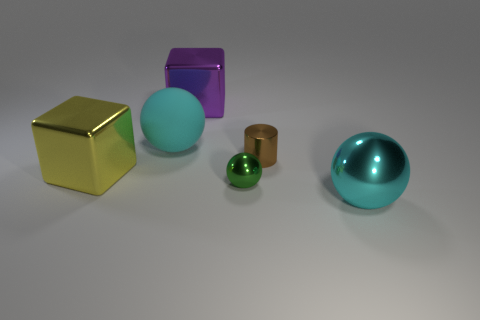Is there anything else that is the same shape as the brown shiny thing?
Your response must be concise. No. There is a rubber object; what number of large cyan metallic objects are behind it?
Provide a short and direct response. 0. What material is the object that is both on the left side of the big purple object and behind the large yellow block?
Provide a succinct answer. Rubber. How many brown metallic cylinders have the same size as the green object?
Your response must be concise. 1. There is a large metal thing left of the large metallic object behind the tiny brown object; what color is it?
Provide a short and direct response. Yellow. Are any small brown cylinders visible?
Offer a very short reply. Yes. Does the small green shiny thing have the same shape as the large cyan metal thing?
Offer a terse response. Yes. How many brown objects are to the left of the cyan object left of the cyan metallic sphere?
Offer a terse response. 0. How many large metallic things are on the left side of the brown object and in front of the tiny brown cylinder?
Your response must be concise. 1. How many things are tiny gray things or large cyan spheres that are on the left side of the purple cube?
Your answer should be very brief. 1. 